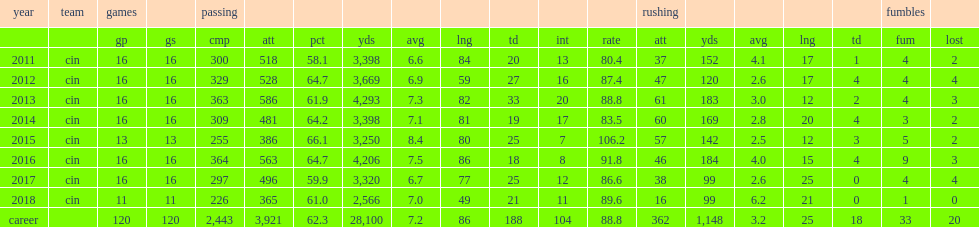How many yards did dalton finish the year with? 3250.0. How many touchdowns did dalton finish the year with? 25.0. How many interceptions did dalton finish the year with? 7.0. 